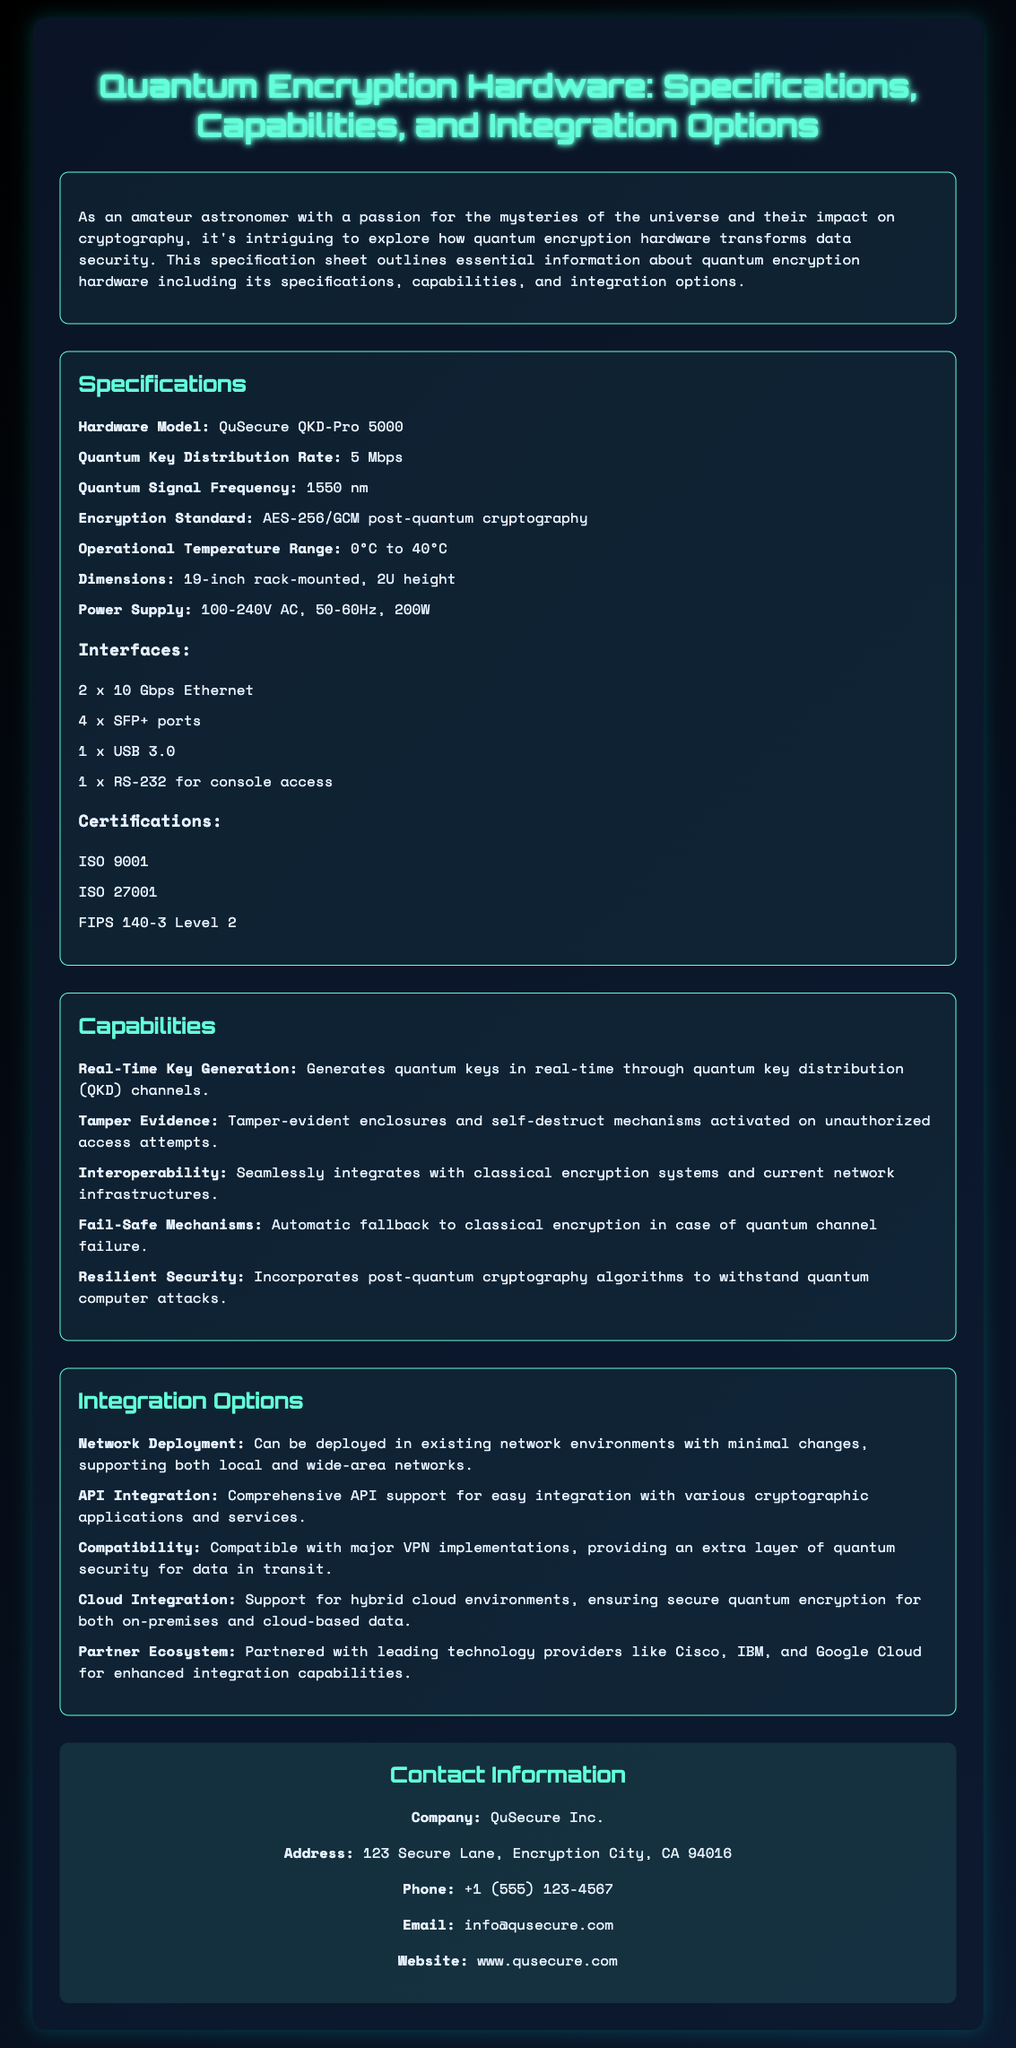What is the hardware model? The hardware model is specified in the "Specifications" section of the document, which is QuSecure QKD-Pro 5000.
Answer: QuSecure QKD-Pro 5000 What is the quantum key distribution rate? The quantum key distribution rate is mentioned in the "Specifications" section, which states it is 5 Mbps.
Answer: 5 Mbps What is the encryption standard used? The encryption standard is listed under "Specifications" and is AES-256/GCM post-quantum cryptography.
Answer: AES-256/GCM post-quantum cryptography What temperature range is the hardware operational? The operational temperature range is detailed in the "Specifications" section, which is from 0°C to 40°C.
Answer: 0°C to 40°C What type of mechanism is incorporated for unauthorized access attempts? The "Capabilities" section discusses tamper-evident enclosures and self-destruct mechanisms in case of unauthorized access attempts.
Answer: Tamper-evident enclosures and self-destruct mechanisms How can the hardware be integrated into existing networks? Integration options include minimal changes to the existing network environments, as mentioned under "Integration Options."
Answer: Minimal changes Which companies is QuSecure partnered with for enhanced integration capabilities? The "Partner Ecosystem" section provides details on partnerships with leading technology providers, including Cisco, IBM, and Google Cloud.
Answer: Cisco, IBM, and Google Cloud What is the power supply requirement for the hardware? The power supply requirement is specified under the "Specifications" section, which states 100-240V AC, 50-60Hz, 200W.
Answer: 100-240V AC, 50-60Hz, 200W What kind of security does the hardware provide for data in transit? The "Integration Options" section mentions it provides an extra layer of quantum security when compatible with major VPN implementations.
Answer: Quantum security for data in transit 